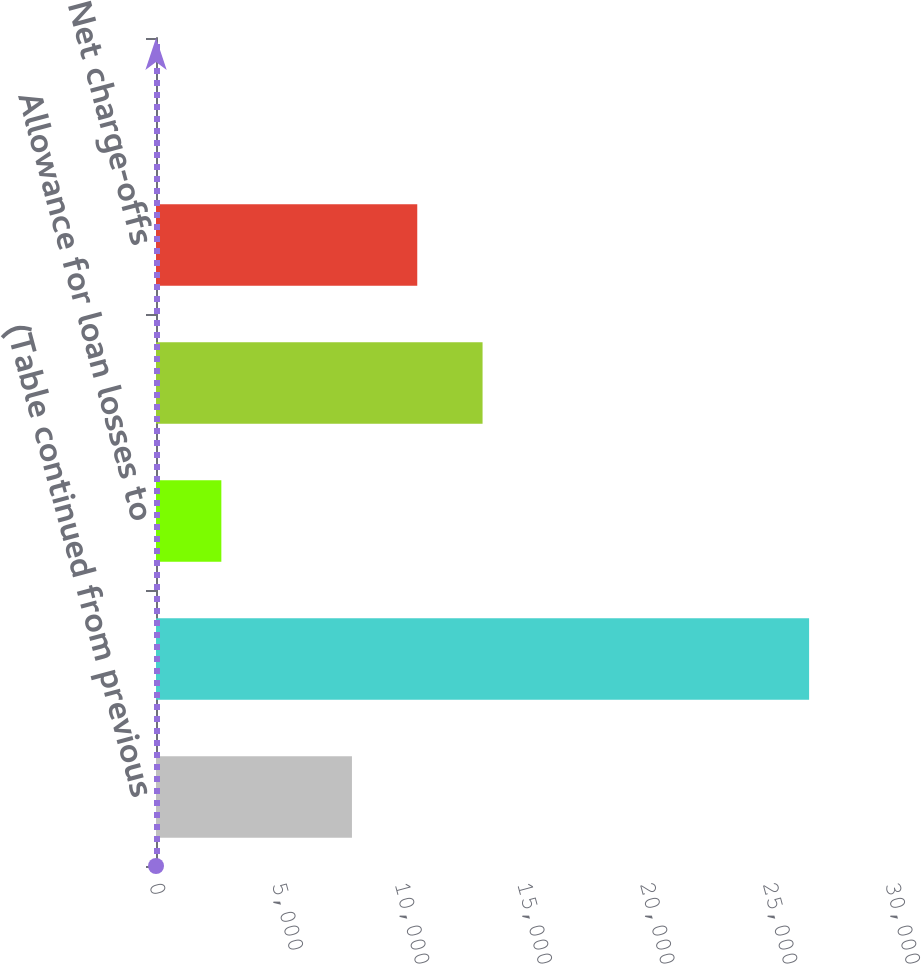<chart> <loc_0><loc_0><loc_500><loc_500><bar_chart><fcel>(Table continued from previous<fcel>Allowance for credit losses<fcel>Allowance for loan losses to<fcel>Nonperforming assets<fcel>Net charge-offs<fcel>Net charge-off rate<nl><fcel>7987.24<fcel>26621<fcel>2663.32<fcel>13311.2<fcel>10649.2<fcel>1.35<nl></chart> 